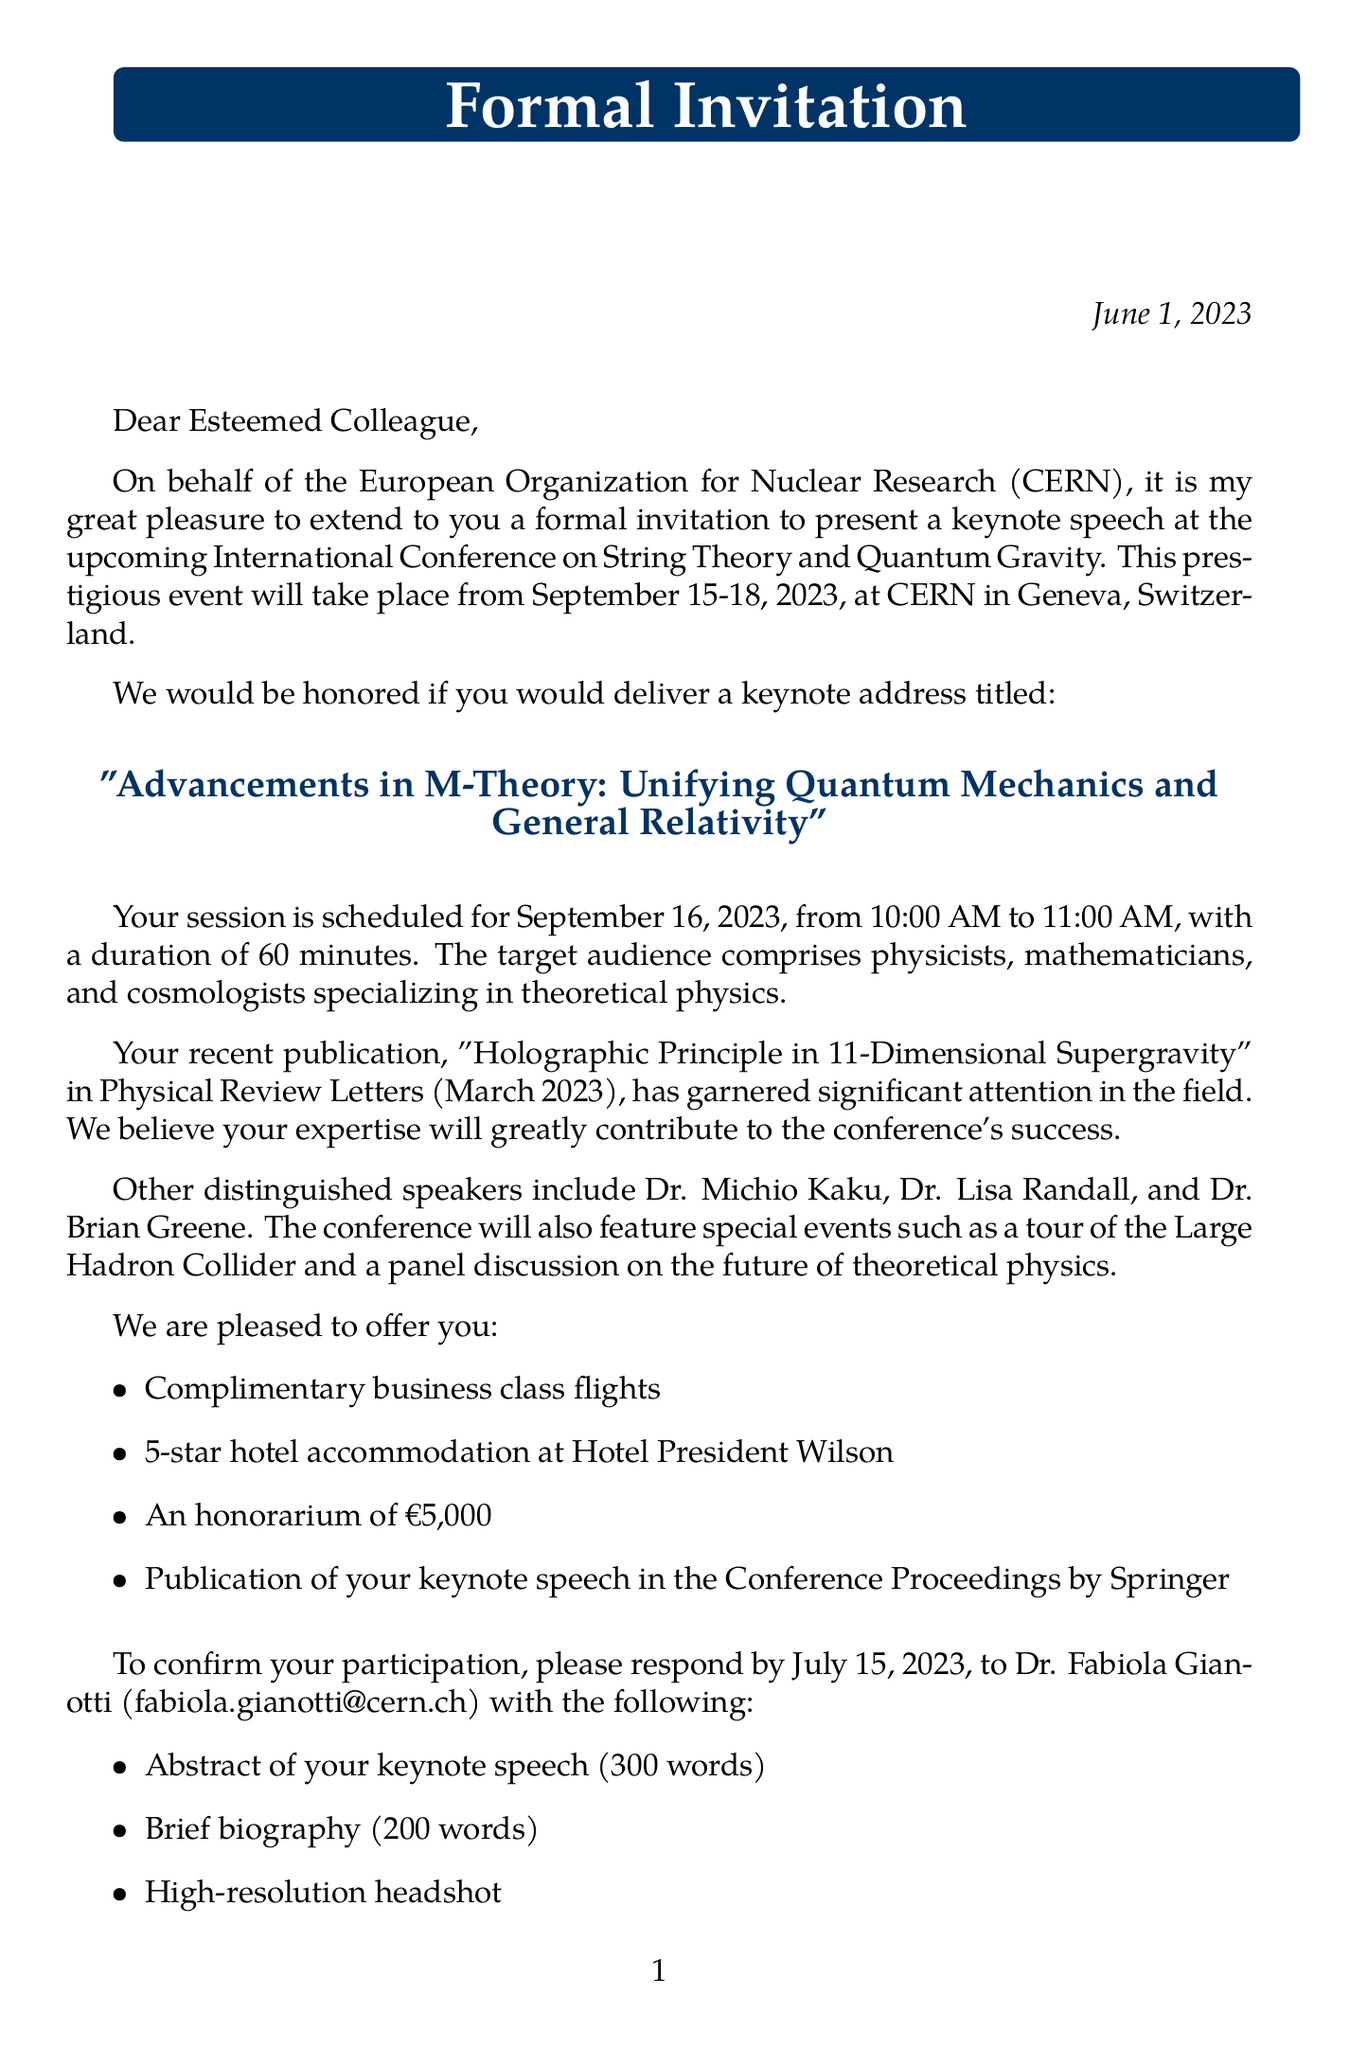What is the name of the conference? The name of the conference is explicitly stated in the document.
Answer: International Conference on String Theory and Quantum Gravity What is the date of the event? The date is clearly mentioned in the document.
Answer: September 15-18, 2023 Who is the invitee's recent publication authored by? The document specifies the title and the journal of the publication, but the author is not directly mentioned.
Answer: Not specified What is the honorarium offered to the keynote speaker? The honorarium amount is listed in the practical information section of the document.
Answer: €5,000 Which organization is hosting the conference? The organizer of the conference is explicitly mentioned in the letter.
Answer: European Organization for Nuclear Research What is the duration of the keynote speech? The duration is specified in the invitation specifics section of the document.
Answer: 60 minutes What is required for the RSVP by the deadline? The document lists what needs to be sent with the RSVP.
Answer: Abstract, biography, headshot What is the target audience for the keynote speech? The target audience is mentioned in the invitation specifics section of the document.
Answer: Physicists, mathematicians, and cosmologists specializing in theoretical physics What is the title of the keynote speech? The title is highlighted in the formal invitation part of the document.
Answer: Advancements in M-Theory: Unifying Quantum Mechanics and General Relativity When should the invitee respond by? The deadline for the response is provided in the response requirements section of the document.
Answer: July 15, 2023 